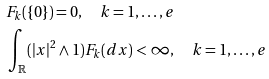<formula> <loc_0><loc_0><loc_500><loc_500>& F _ { k } ( \{ 0 \} ) = 0 , \quad k = 1 , \dots , e \\ & \int _ { \mathbb { R } } ( | x | ^ { 2 } \wedge 1 ) F _ { k } ( d x ) < \infty , \quad k = 1 , \dots , e</formula> 